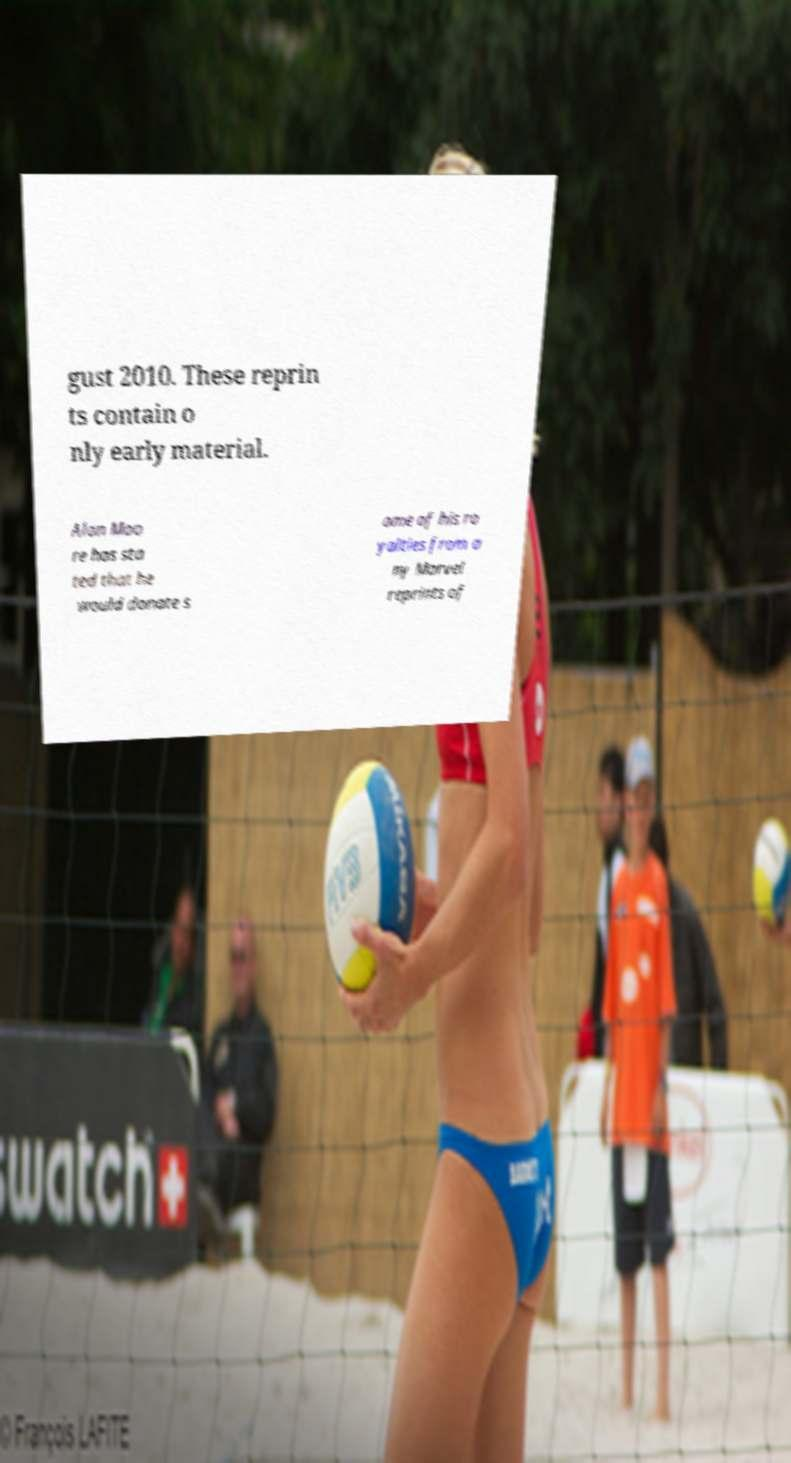Can you accurately transcribe the text from the provided image for me? gust 2010. These reprin ts contain o nly early material. Alan Moo re has sta ted that he would donate s ome of his ro yalties from a ny Marvel reprints of 